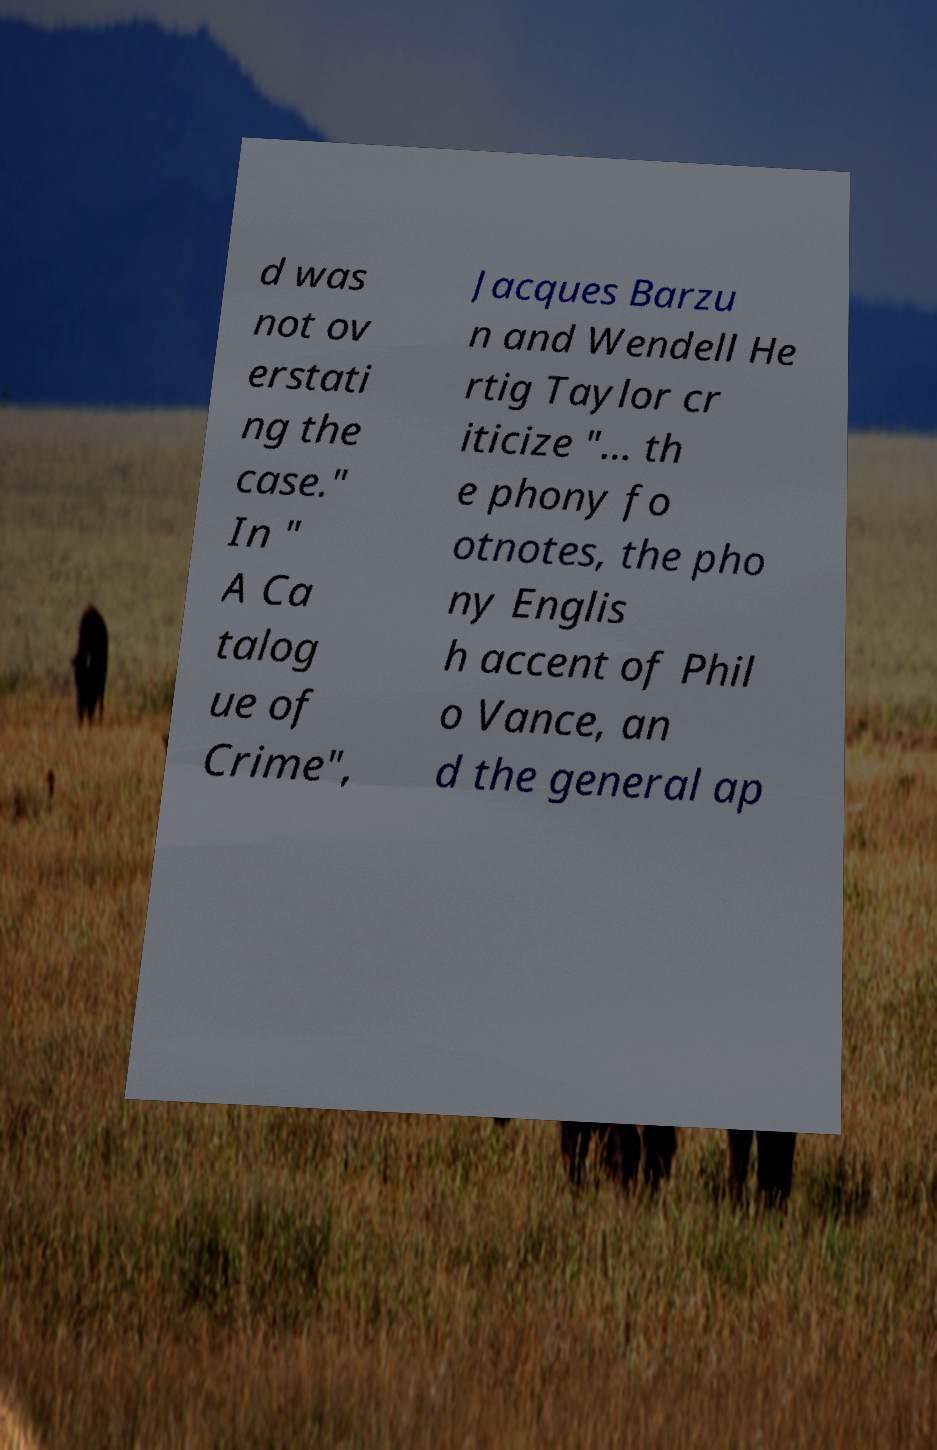Please identify and transcribe the text found in this image. d was not ov erstati ng the case." In " A Ca talog ue of Crime", Jacques Barzu n and Wendell He rtig Taylor cr iticize "… th e phony fo otnotes, the pho ny Englis h accent of Phil o Vance, an d the general ap 